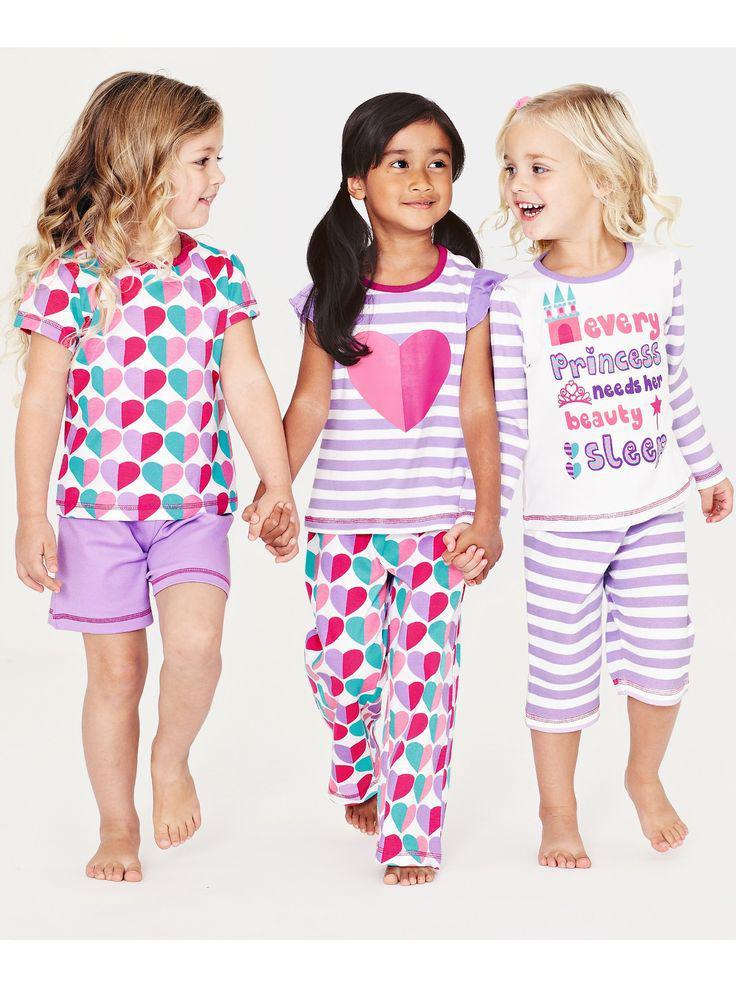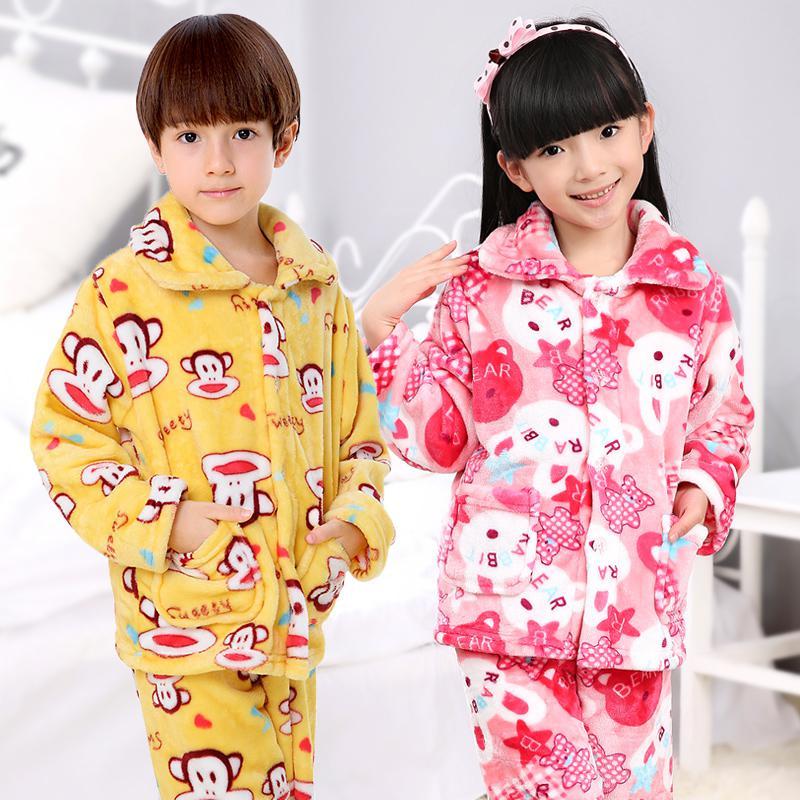The first image is the image on the left, the second image is the image on the right. Evaluate the accuracy of this statement regarding the images: "The right image contains three children.". Is it true? Answer yes or no. No. The first image is the image on the left, the second image is the image on the right. For the images shown, is this caption "One girl is wearing shorts." true? Answer yes or no. Yes. 